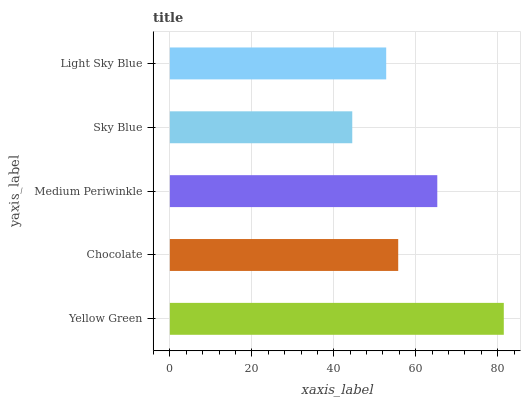Is Sky Blue the minimum?
Answer yes or no. Yes. Is Yellow Green the maximum?
Answer yes or no. Yes. Is Chocolate the minimum?
Answer yes or no. No. Is Chocolate the maximum?
Answer yes or no. No. Is Yellow Green greater than Chocolate?
Answer yes or no. Yes. Is Chocolate less than Yellow Green?
Answer yes or no. Yes. Is Chocolate greater than Yellow Green?
Answer yes or no. No. Is Yellow Green less than Chocolate?
Answer yes or no. No. Is Chocolate the high median?
Answer yes or no. Yes. Is Chocolate the low median?
Answer yes or no. Yes. Is Light Sky Blue the high median?
Answer yes or no. No. Is Yellow Green the low median?
Answer yes or no. No. 